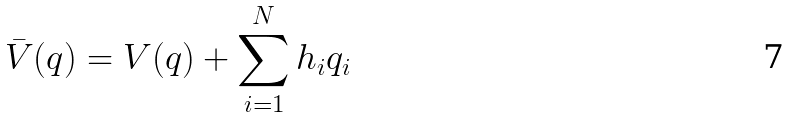<formula> <loc_0><loc_0><loc_500><loc_500>\bar { V } ( q ) = V ( q ) + \sum _ { i = 1 } ^ { N } h _ { i } q _ { i }</formula> 